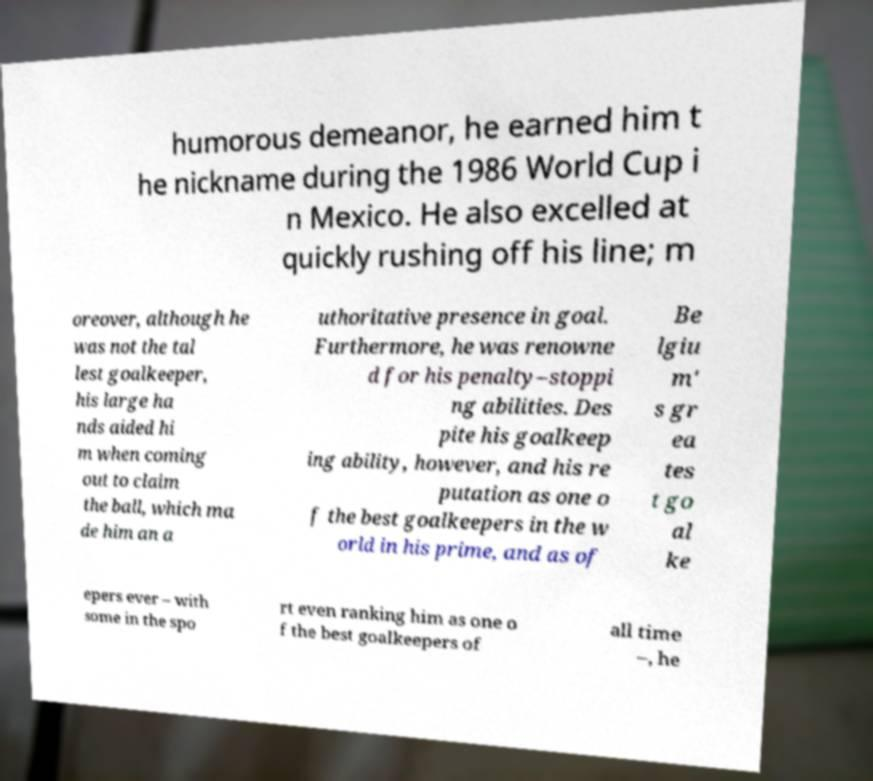For documentation purposes, I need the text within this image transcribed. Could you provide that? humorous demeanor, he earned him t he nickname during the 1986 World Cup i n Mexico. He also excelled at quickly rushing off his line; m oreover, although he was not the tal lest goalkeeper, his large ha nds aided hi m when coming out to claim the ball, which ma de him an a uthoritative presence in goal. Furthermore, he was renowne d for his penalty–stoppi ng abilities. Des pite his goalkeep ing ability, however, and his re putation as one o f the best goalkeepers in the w orld in his prime, and as of Be lgiu m' s gr ea tes t go al ke epers ever – with some in the spo rt even ranking him as one o f the best goalkeepers of all time –, he 